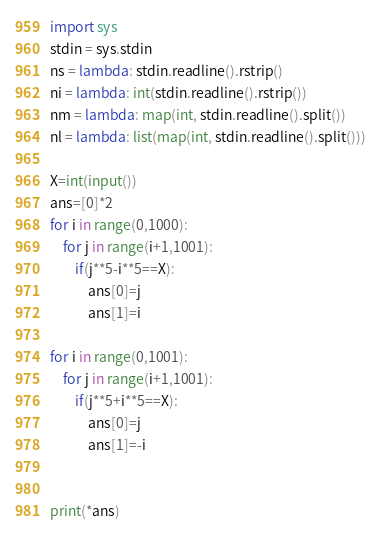<code> <loc_0><loc_0><loc_500><loc_500><_Python_>import sys
stdin = sys.stdin
ns = lambda: stdin.readline().rstrip()
ni = lambda: int(stdin.readline().rstrip())
nm = lambda: map(int, stdin.readline().split())
nl = lambda: list(map(int, stdin.readline().split()))

X=int(input())
ans=[0]*2
for i in range(0,1000):
    for j in range(i+1,1001):
        if(j**5-i**5==X):
            ans[0]=j
            ans[1]=i

for i in range(0,1001):
    for j in range(i+1,1001):
        if(j**5+i**5==X):
            ans[0]=j
            ans[1]=-i


print(*ans)</code> 